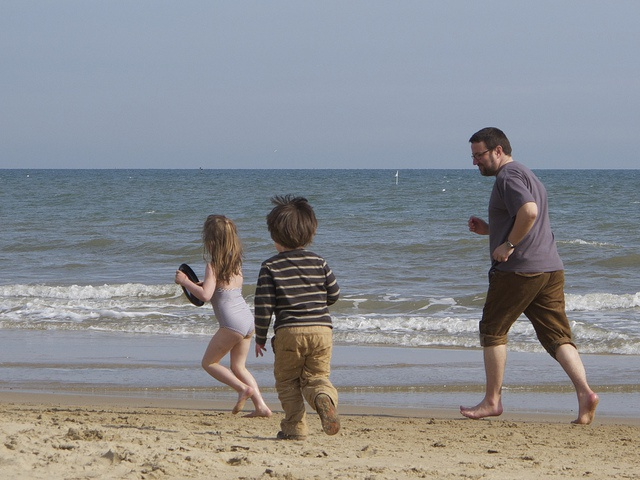Describe the objects in this image and their specific colors. I can see people in darkgray, black, gray, and maroon tones, people in darkgray, black, maroon, and gray tones, people in darkgray, gray, and brown tones, and frisbee in darkgray, black, gray, and tan tones in this image. 